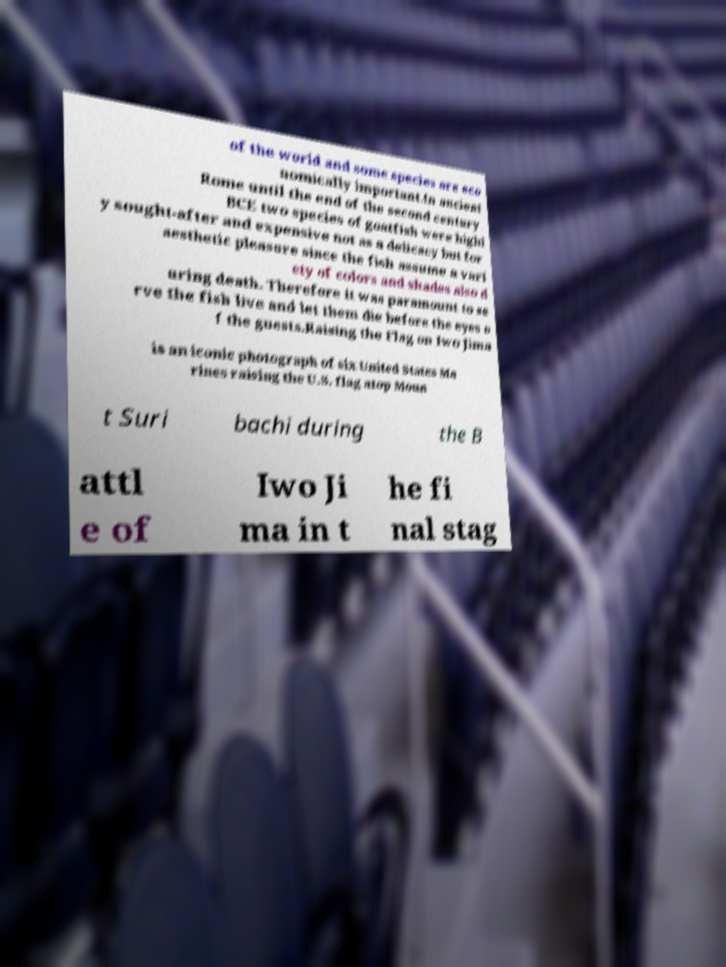Please read and relay the text visible in this image. What does it say? of the world and some species are eco nomically important.In ancient Rome until the end of the second century BCE two species of goatfish were highl y sought-after and expensive not as a delicacy but for aesthetic pleasure since the fish assume a vari ety of colors and shades also d uring death. Therefore it was paramount to se rve the fish live and let them die before the eyes o f the guests.Raising the Flag on Iwo Jima is an iconic photograph of six United States Ma rines raising the U.S. flag atop Moun t Suri bachi during the B attl e of Iwo Ji ma in t he fi nal stag 